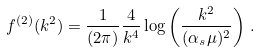Convert formula to latex. <formula><loc_0><loc_0><loc_500><loc_500>f ^ { ( 2 ) } ( k ^ { 2 } ) = \frac { 1 } { ( 2 \pi ) } \frac { 4 } { k ^ { 4 } } \log \left ( \frac { k ^ { 2 } } { ( \alpha _ { s } \mu ) ^ { 2 } } \right ) \, .</formula> 